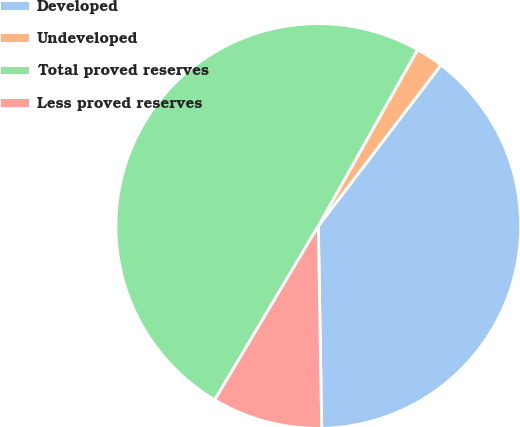Convert chart to OTSL. <chart><loc_0><loc_0><loc_500><loc_500><pie_chart><fcel>Developed<fcel>Undeveloped<fcel>Total proved reserves<fcel>Less proved reserves<nl><fcel>39.37%<fcel>2.2%<fcel>49.61%<fcel>8.81%<nl></chart> 